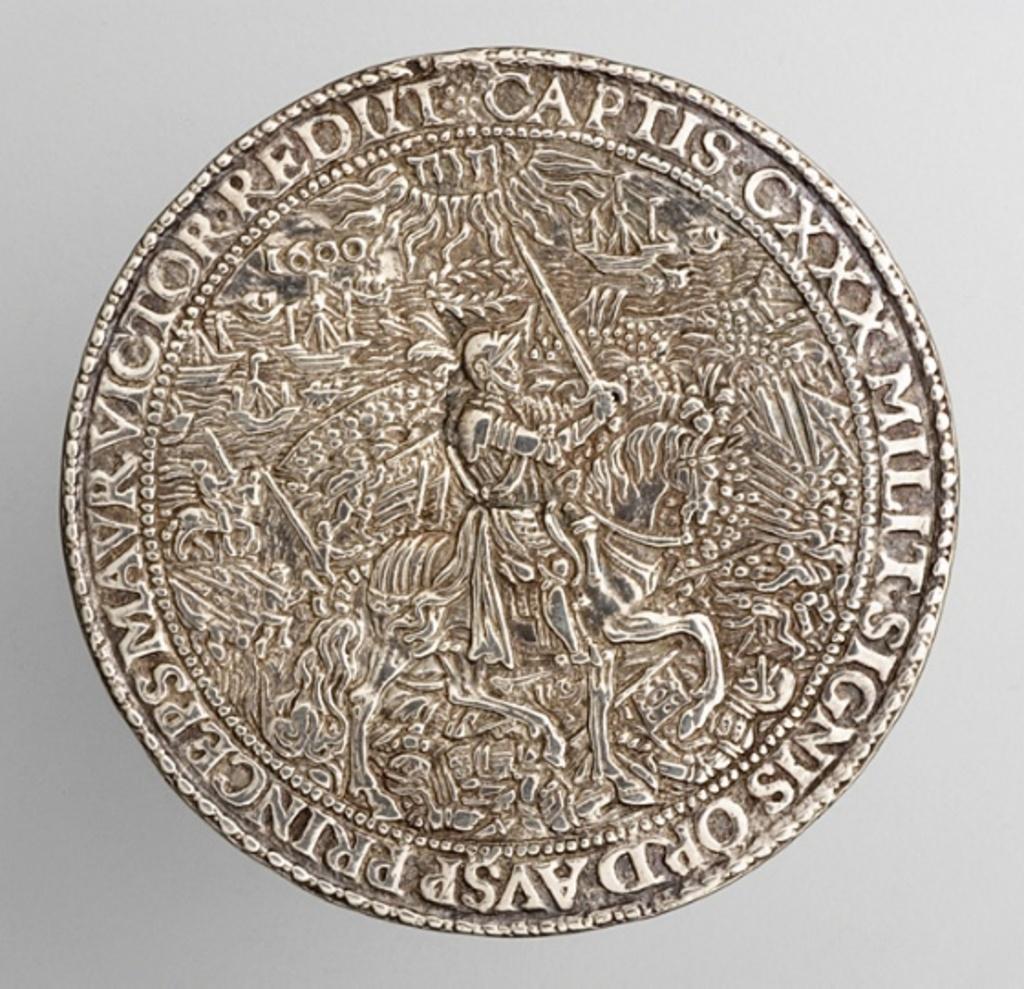What number is found written in roman numerals?
Give a very brief answer. Gxxx. 